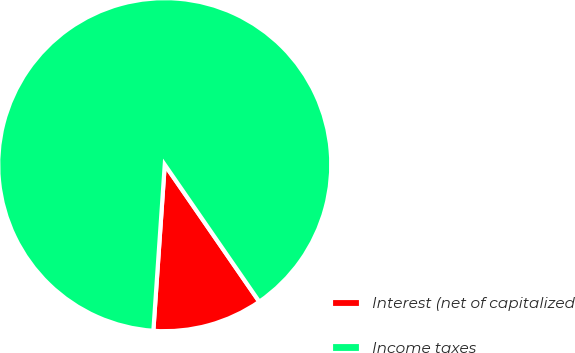Convert chart. <chart><loc_0><loc_0><loc_500><loc_500><pie_chart><fcel>Interest (net of capitalized<fcel>Income taxes<nl><fcel>10.7%<fcel>89.3%<nl></chart> 